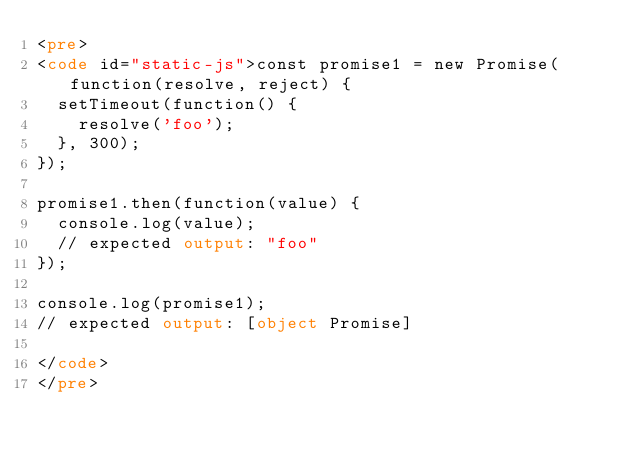<code> <loc_0><loc_0><loc_500><loc_500><_HTML_><pre>
<code id="static-js">const promise1 = new Promise(function(resolve, reject) {
  setTimeout(function() {
    resolve('foo');
  }, 300);
});

promise1.then(function(value) {
  console.log(value);
  // expected output: "foo"
});

console.log(promise1);
// expected output: [object Promise]

</code>
</pre>
</code> 